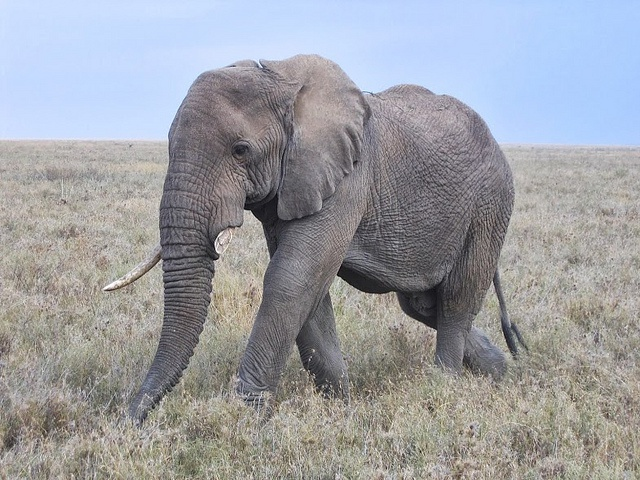Describe the objects in this image and their specific colors. I can see a elephant in lavender, gray, darkgray, and black tones in this image. 